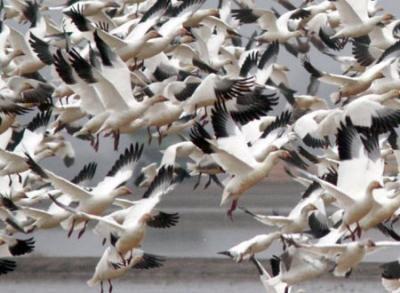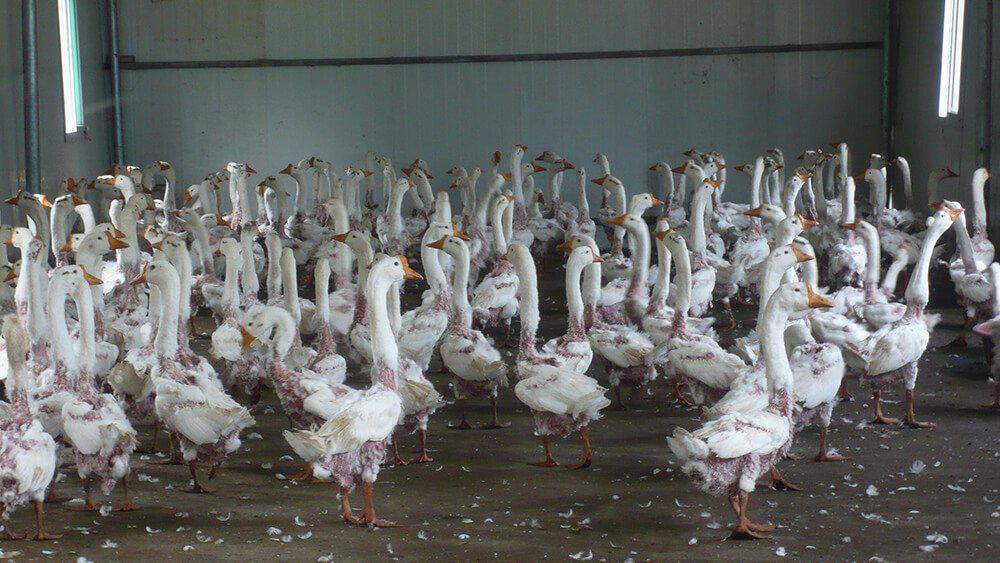The first image is the image on the left, the second image is the image on the right. For the images shown, is this caption "At least one goose has a black neck and beak, and a grey body." true? Answer yes or no. No. The first image is the image on the left, the second image is the image on the right. Examine the images to the left and right. Is the description "In at least one image there are Blacked becked birds touching the water." accurate? Answer yes or no. No. 